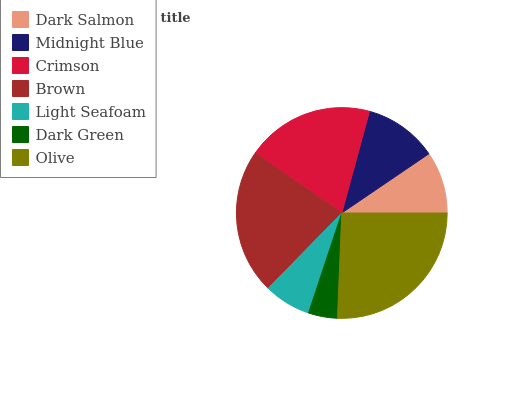Is Dark Green the minimum?
Answer yes or no. Yes. Is Olive the maximum?
Answer yes or no. Yes. Is Midnight Blue the minimum?
Answer yes or no. No. Is Midnight Blue the maximum?
Answer yes or no. No. Is Midnight Blue greater than Dark Salmon?
Answer yes or no. Yes. Is Dark Salmon less than Midnight Blue?
Answer yes or no. Yes. Is Dark Salmon greater than Midnight Blue?
Answer yes or no. No. Is Midnight Blue less than Dark Salmon?
Answer yes or no. No. Is Midnight Blue the high median?
Answer yes or no. Yes. Is Midnight Blue the low median?
Answer yes or no. Yes. Is Brown the high median?
Answer yes or no. No. Is Light Seafoam the low median?
Answer yes or no. No. 